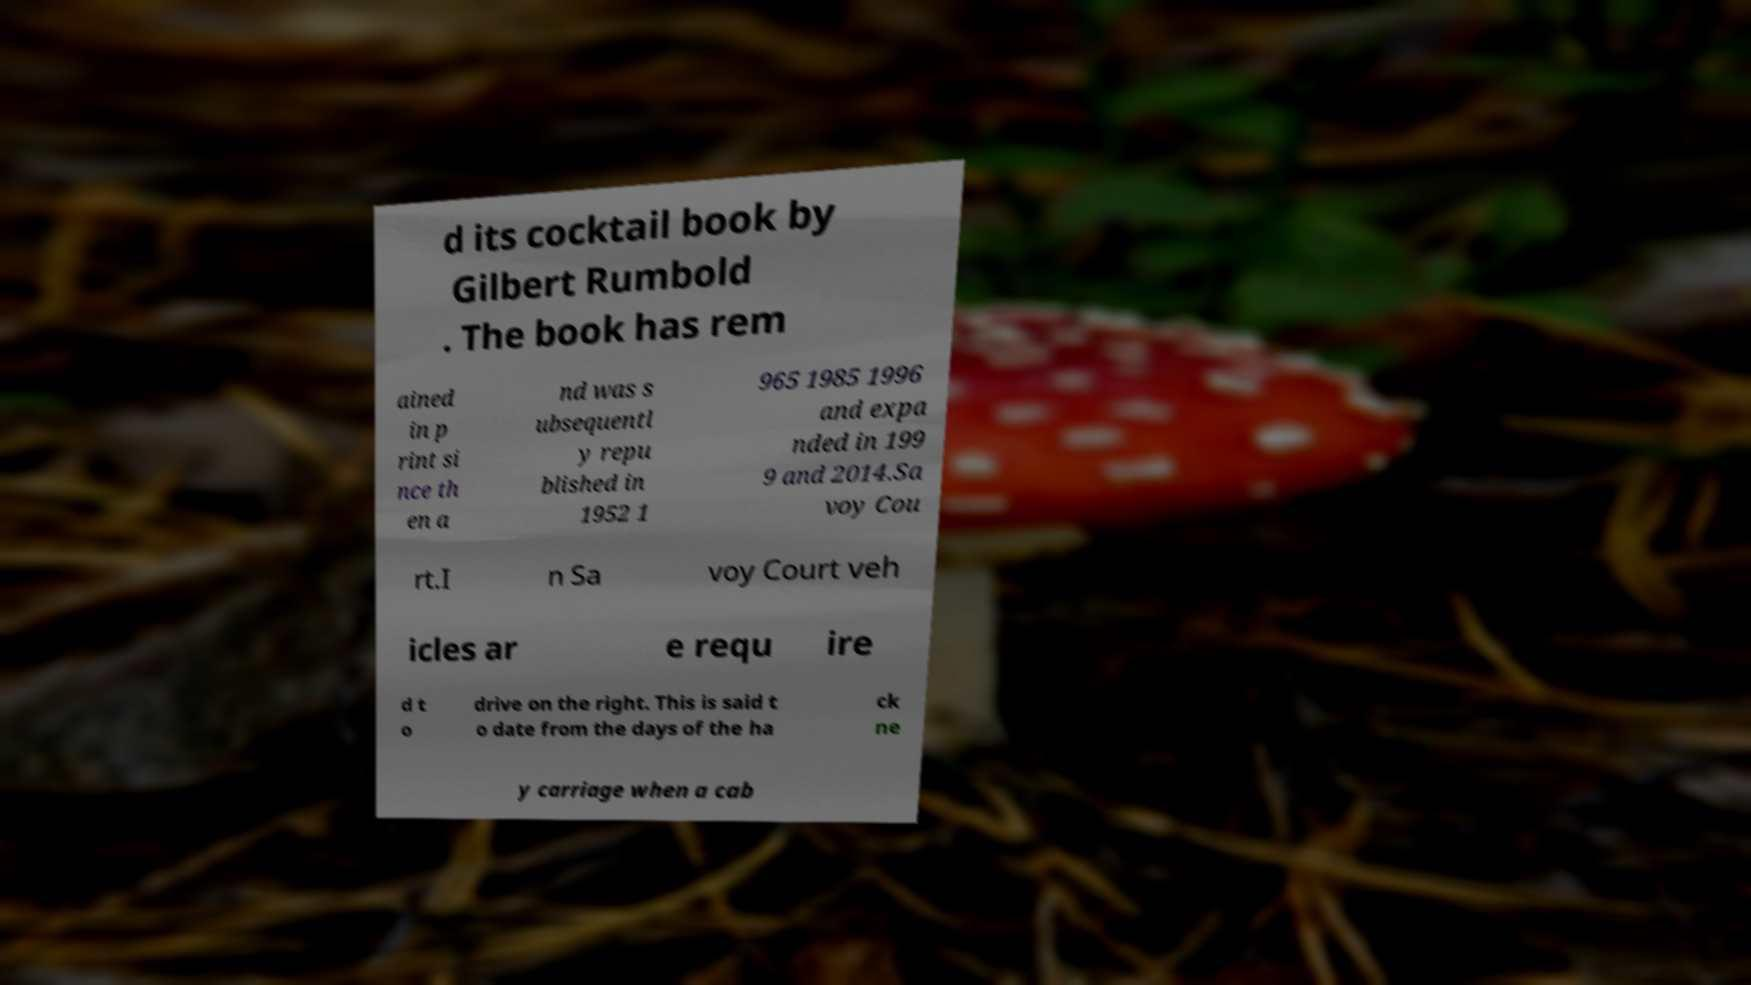Please identify and transcribe the text found in this image. d its cocktail book by Gilbert Rumbold . The book has rem ained in p rint si nce th en a nd was s ubsequentl y repu blished in 1952 1 965 1985 1996 and expa nded in 199 9 and 2014.Sa voy Cou rt.I n Sa voy Court veh icles ar e requ ire d t o drive on the right. This is said t o date from the days of the ha ck ne y carriage when a cab 